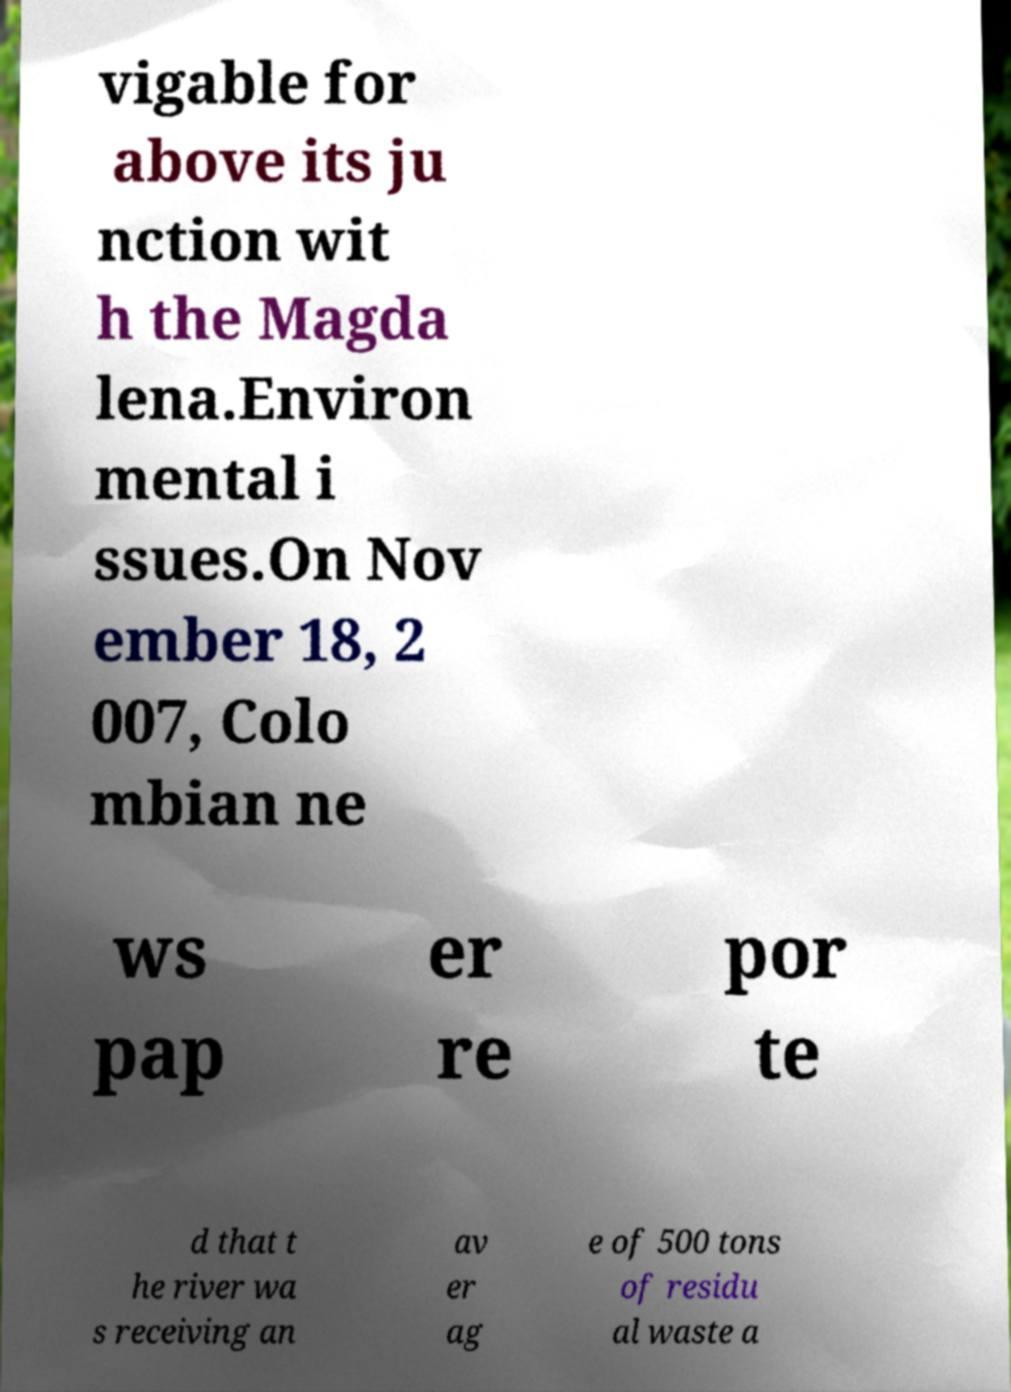For documentation purposes, I need the text within this image transcribed. Could you provide that? vigable for above its ju nction wit h the Magda lena.Environ mental i ssues.On Nov ember 18, 2 007, Colo mbian ne ws pap er re por te d that t he river wa s receiving an av er ag e of 500 tons of residu al waste a 